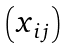<formula> <loc_0><loc_0><loc_500><loc_500>\begin{pmatrix} x _ { i j } \end{pmatrix}</formula> 